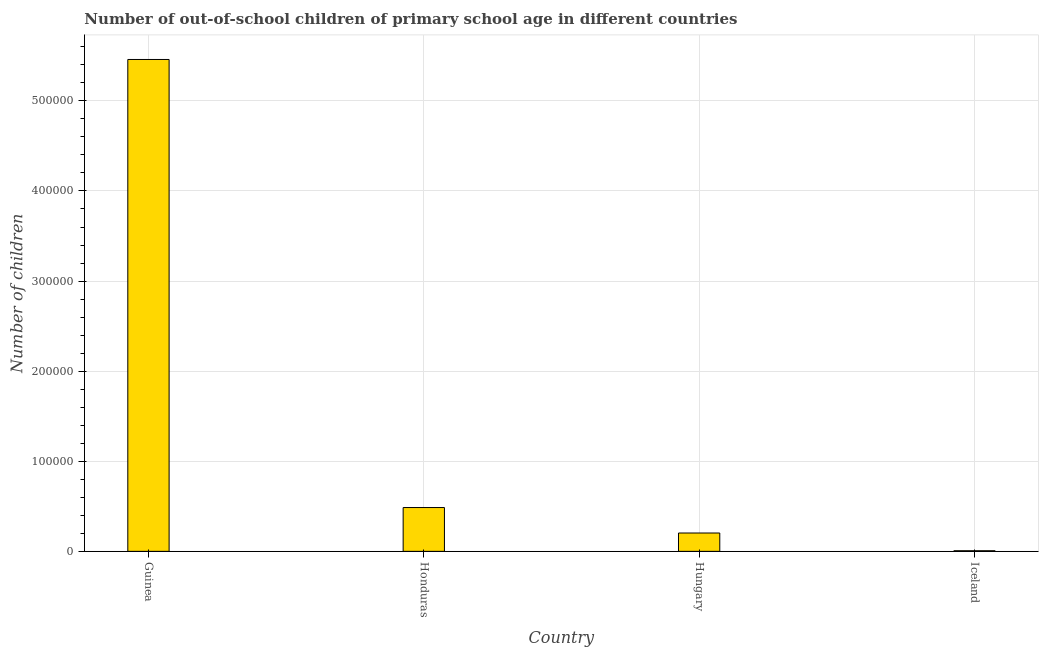Does the graph contain any zero values?
Ensure brevity in your answer.  No. Does the graph contain grids?
Provide a short and direct response. Yes. What is the title of the graph?
Your answer should be compact. Number of out-of-school children of primary school age in different countries. What is the label or title of the Y-axis?
Offer a very short reply. Number of children. What is the number of out-of-school children in Iceland?
Your answer should be compact. 690. Across all countries, what is the maximum number of out-of-school children?
Your response must be concise. 5.46e+05. Across all countries, what is the minimum number of out-of-school children?
Ensure brevity in your answer.  690. In which country was the number of out-of-school children maximum?
Offer a terse response. Guinea. What is the sum of the number of out-of-school children?
Make the answer very short. 6.16e+05. What is the difference between the number of out-of-school children in Honduras and Hungary?
Keep it short and to the point. 2.83e+04. What is the average number of out-of-school children per country?
Offer a terse response. 1.54e+05. What is the median number of out-of-school children?
Keep it short and to the point. 3.45e+04. What is the ratio of the number of out-of-school children in Honduras to that in Iceland?
Your answer should be very brief. 70.47. Is the number of out-of-school children in Honduras less than that in Hungary?
Offer a terse response. No. Is the difference between the number of out-of-school children in Hungary and Iceland greater than the difference between any two countries?
Ensure brevity in your answer.  No. What is the difference between the highest and the second highest number of out-of-school children?
Offer a very short reply. 4.97e+05. Is the sum of the number of out-of-school children in Hungary and Iceland greater than the maximum number of out-of-school children across all countries?
Ensure brevity in your answer.  No. What is the difference between the highest and the lowest number of out-of-school children?
Offer a very short reply. 5.45e+05. In how many countries, is the number of out-of-school children greater than the average number of out-of-school children taken over all countries?
Make the answer very short. 1. How many bars are there?
Keep it short and to the point. 4. How many countries are there in the graph?
Provide a short and direct response. 4. What is the difference between two consecutive major ticks on the Y-axis?
Your answer should be compact. 1.00e+05. What is the Number of children of Guinea?
Make the answer very short. 5.46e+05. What is the Number of children in Honduras?
Provide a short and direct response. 4.86e+04. What is the Number of children of Hungary?
Keep it short and to the point. 2.04e+04. What is the Number of children of Iceland?
Give a very brief answer. 690. What is the difference between the Number of children in Guinea and Honduras?
Make the answer very short. 4.97e+05. What is the difference between the Number of children in Guinea and Hungary?
Provide a short and direct response. 5.26e+05. What is the difference between the Number of children in Guinea and Iceland?
Offer a terse response. 5.45e+05. What is the difference between the Number of children in Honduras and Hungary?
Provide a short and direct response. 2.83e+04. What is the difference between the Number of children in Honduras and Iceland?
Provide a short and direct response. 4.79e+04. What is the difference between the Number of children in Hungary and Iceland?
Your answer should be very brief. 1.97e+04. What is the ratio of the Number of children in Guinea to that in Honduras?
Provide a succinct answer. 11.23. What is the ratio of the Number of children in Guinea to that in Hungary?
Your answer should be very brief. 26.8. What is the ratio of the Number of children in Guinea to that in Iceland?
Your response must be concise. 791.22. What is the ratio of the Number of children in Honduras to that in Hungary?
Offer a very short reply. 2.39. What is the ratio of the Number of children in Honduras to that in Iceland?
Give a very brief answer. 70.47. What is the ratio of the Number of children in Hungary to that in Iceland?
Provide a succinct answer. 29.53. 